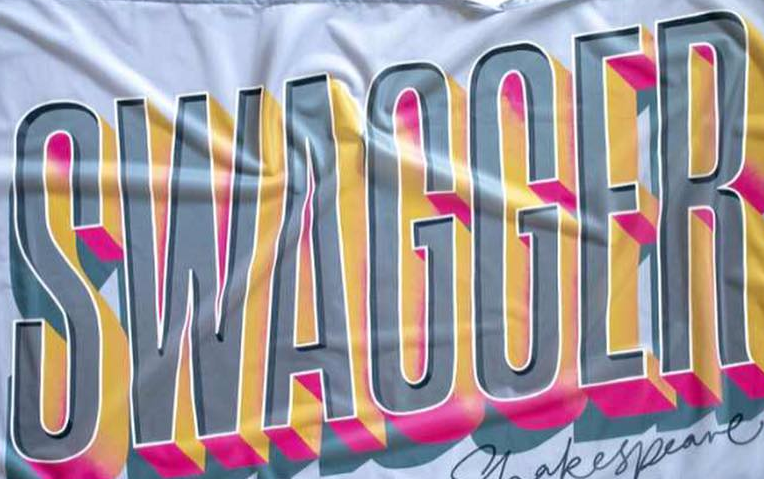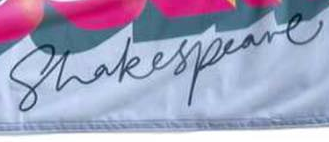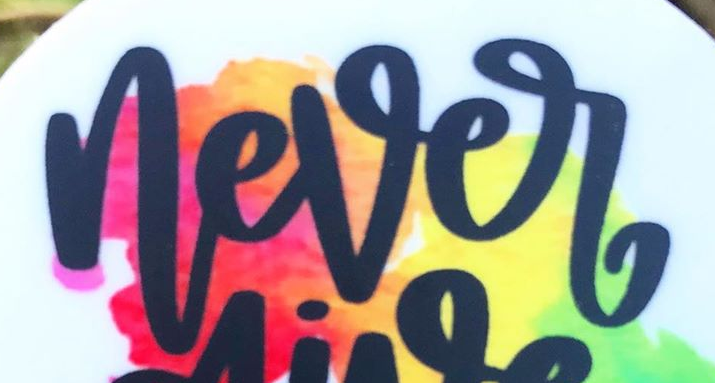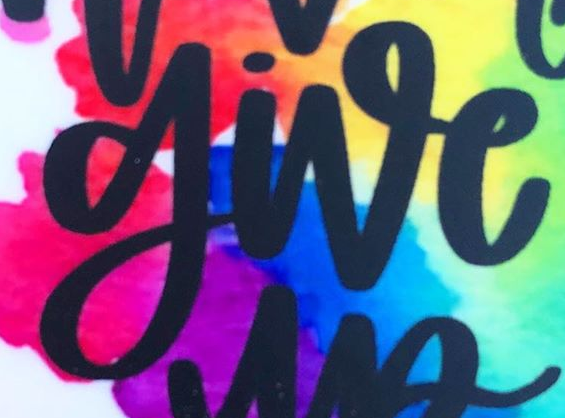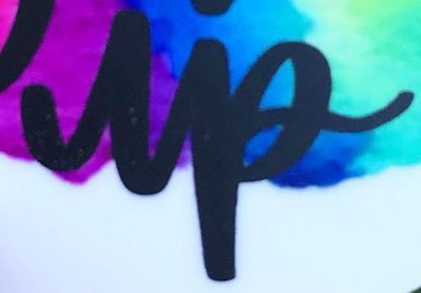Read the text from these images in sequence, separated by a semicolon. SWAGGER; Shakespeare; never; give; up 